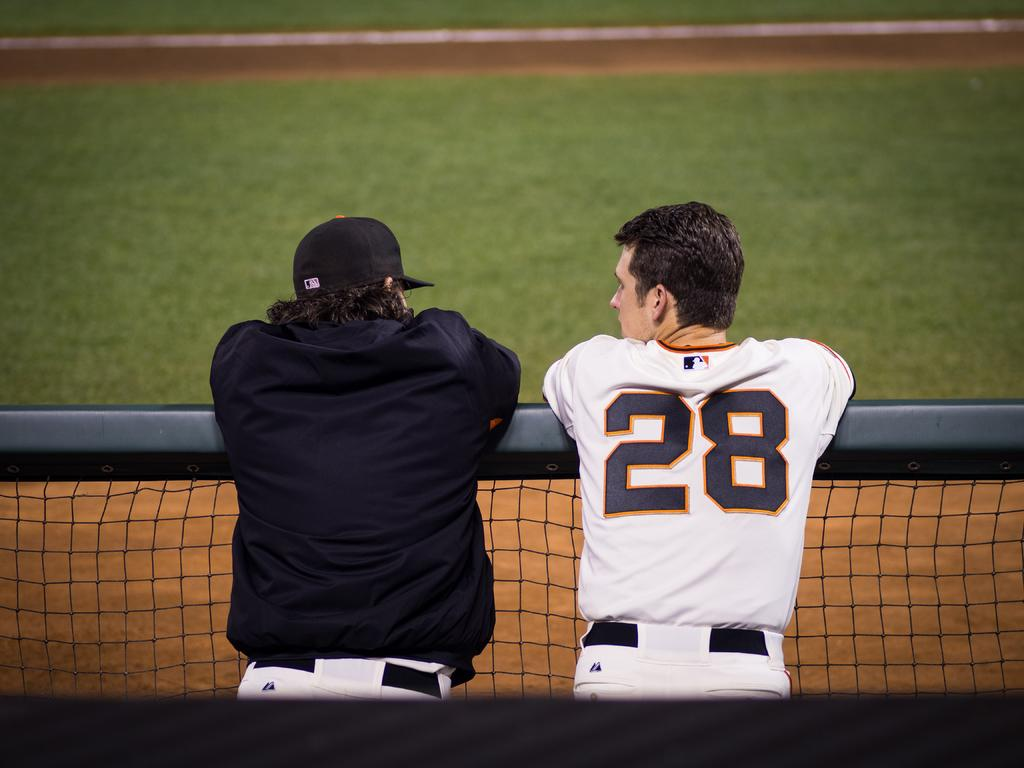<image>
Summarize the visual content of the image. a person with the number 28 on the back of their jersey 